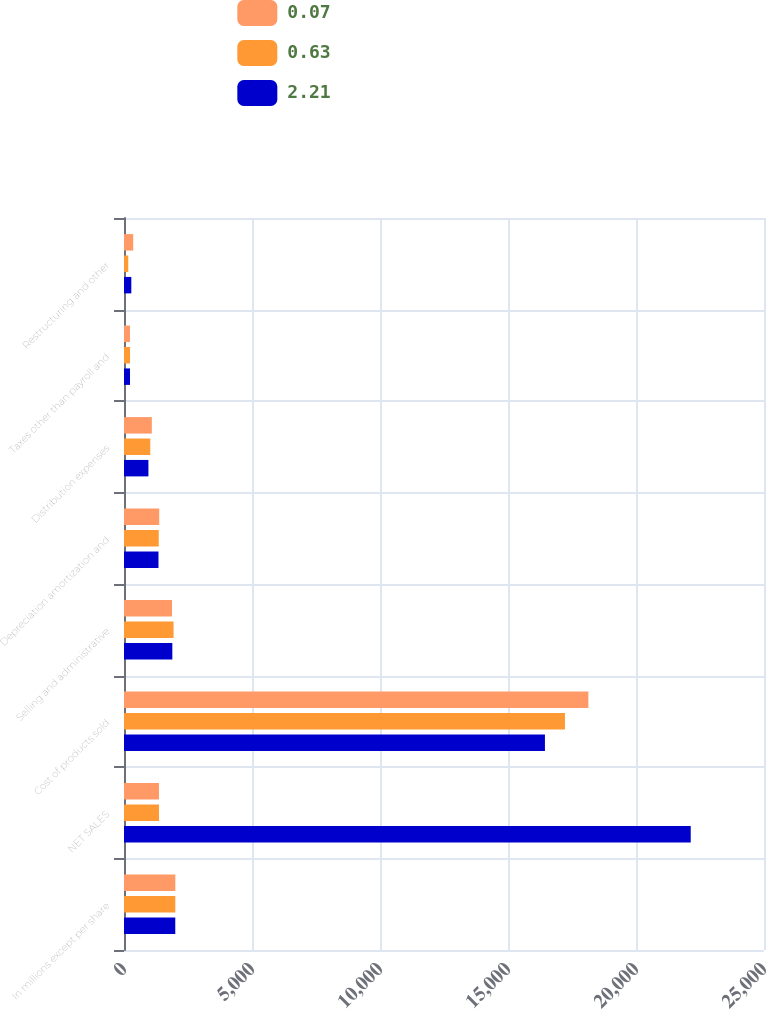<chart> <loc_0><loc_0><loc_500><loc_500><stacked_bar_chart><ecel><fcel>In millions except per share<fcel>NET SALES<fcel>Cost of products sold<fcel>Selling and administrative<fcel>Depreciation amortization and<fcel>Distribution expenses<fcel>Taxes other than payroll and<fcel>Restructuring and other<nl><fcel>0.07<fcel>2005<fcel>1366.5<fcel>18139<fcel>1876<fcel>1376<fcel>1087<fcel>233<fcel>358<nl><fcel>0.63<fcel>2004<fcel>1366.5<fcel>17225<fcel>1935<fcel>1357<fcel>1026<fcel>236<fcel>166<nl><fcel>2.21<fcel>2003<fcel>22138<fcel>16443<fcel>1888<fcel>1347<fcel>954<fcel>235<fcel>286<nl></chart> 